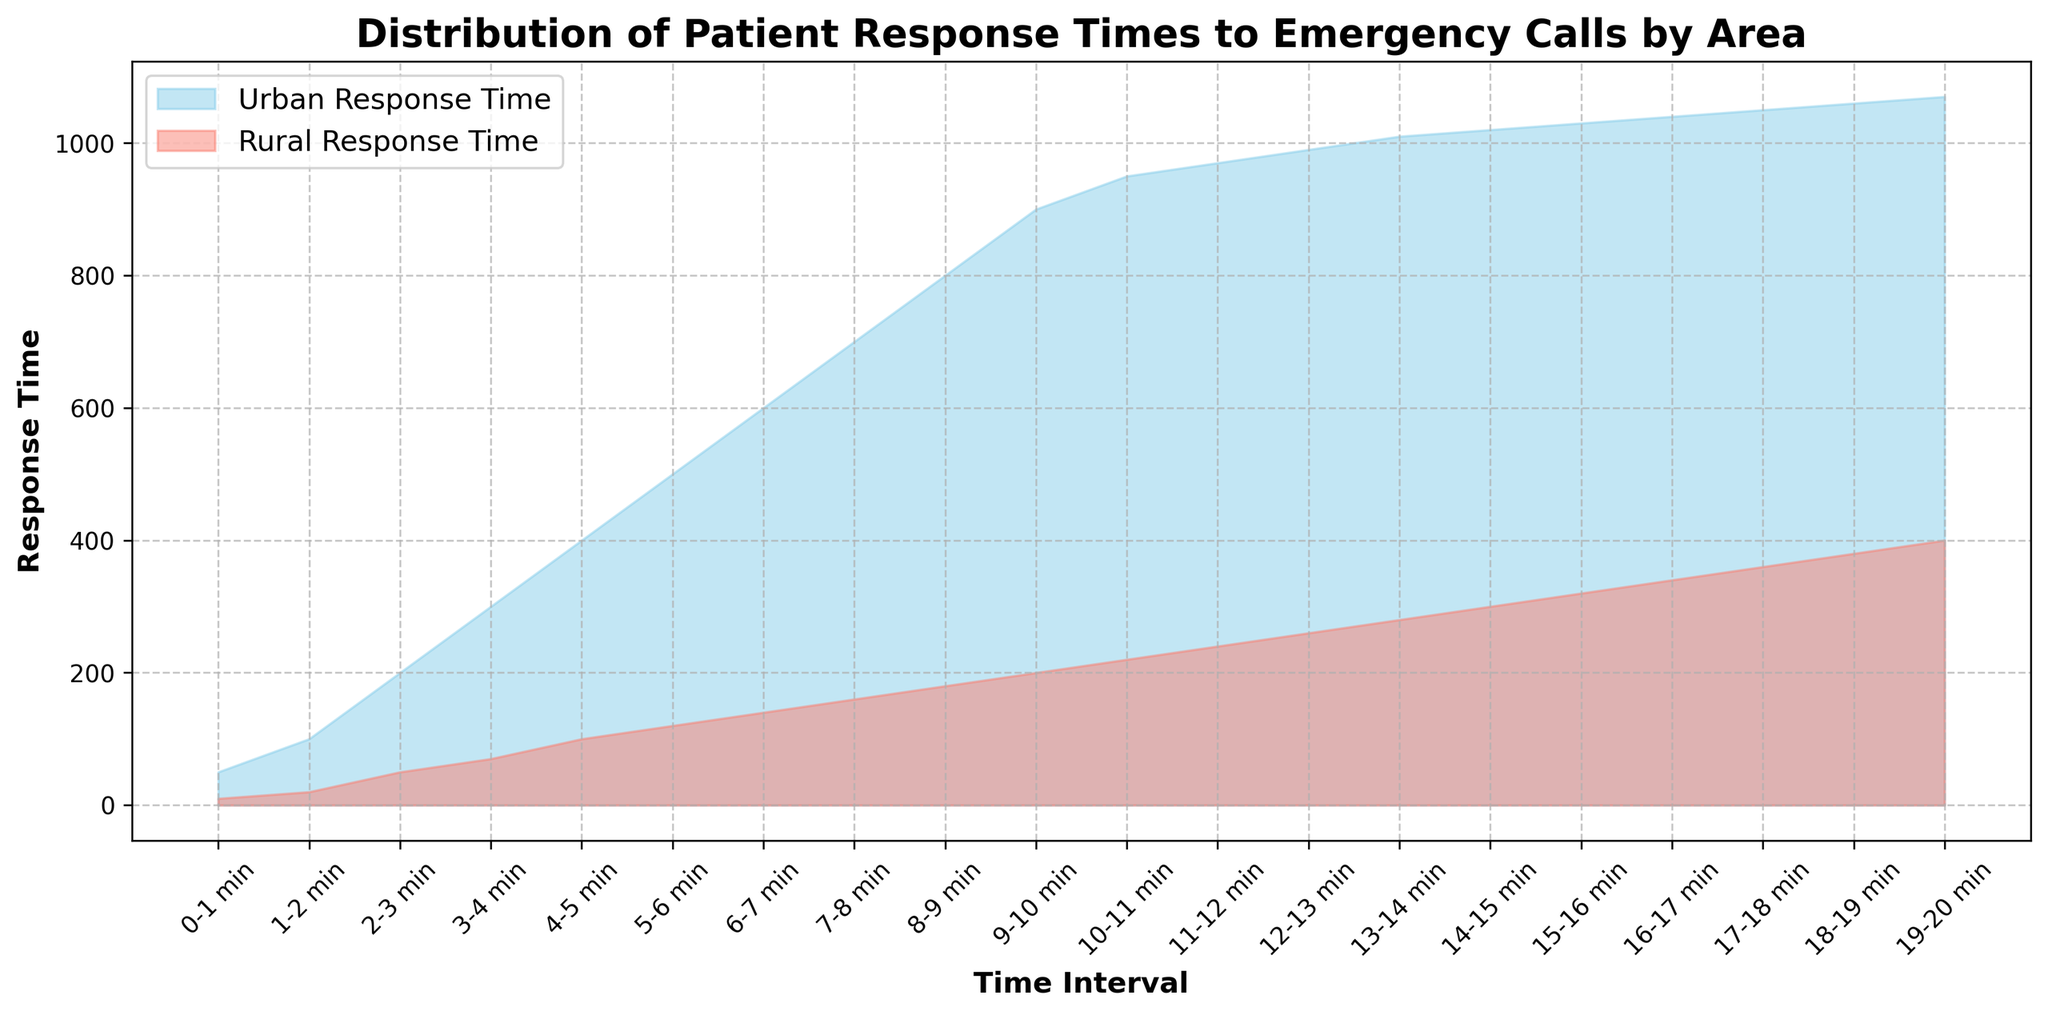What is the response time range for urban areas? The response time range for urban areas is represented by the highest and lowest values within the plotted region for urban response times. The lowest value is at the 0-1 minute interval with 50, and the highest is at the 19-20 minute interval with 1070. Hence, the urban response time ranges from 50 to 1070.
Answer: 50 to 1070 Which area has generally higher response times, urban or rural? By comparing the filled areas of the plotted lines, the urban response time consistently covers a higher region on the plot compared to the rural response time at every interval.
Answer: Urban How do the response times in rural areas between 0-1 min and 19-20 min compare? We need to refer to the chart and compare the height at the 0-1 min interval to the height at the 19-20 min interval for the rural response time. The response time at 0-1 min is 10, whereas at 19-20 min it is 400. Therefore, the response time at 19-20 min is much higher.
Answer: 400 is higher than 10 What is the difference in response time between urban and rural areas at the 10-11 min interval? To find the difference, we subtract the rural response time from the urban response time at the 10-11 minute interval. The urban response time is 950 and the rural response time is 220, so 950 - 220 = 730.
Answer: 730 What time interval shows the greatest discrepancy between urban and rural response times? The greatest discrepancy occurs where the difference between urban and rural response times is the largest. By examining the plot, the 10-11 min interval shows the largest difference, calculated as 950 (urban) - 220 (rural) = 730.
Answer: 10-11 min Which response time grows more rapidly over the first 10 minutes, urban or rural? Analyzing the slopes of the response times in the first 10 minutes, the rate of increase in the filled area for urban response time is much steeper compared to rural. Therefore, urban response time grows more rapidly.
Answer: Urban At which time interval do the rural response times exceed 300? From the chart, rural response times exceed 300 from the 14-15 min interval onward. This can be observed as the fill area for rural time crosses above the 300 mark starting from this interval.
Answer: 14-15 min What is the average response time for urban areas across the given intervals? To calculate this, add the response times for urban areas from all intervals and divide by the number of intervals. Sum = 50 + 100 + 200 + 300 + 400 + 500 + 600 + 700 + 800 + 900 + 950 + 970 + 990 + 1010 + 1020 + 1030 + 1040 + 1050 + 1060 + 1070 = 14900. The number of intervals is 20. Average = 14900 / 20 = 745.
Answer: 745 